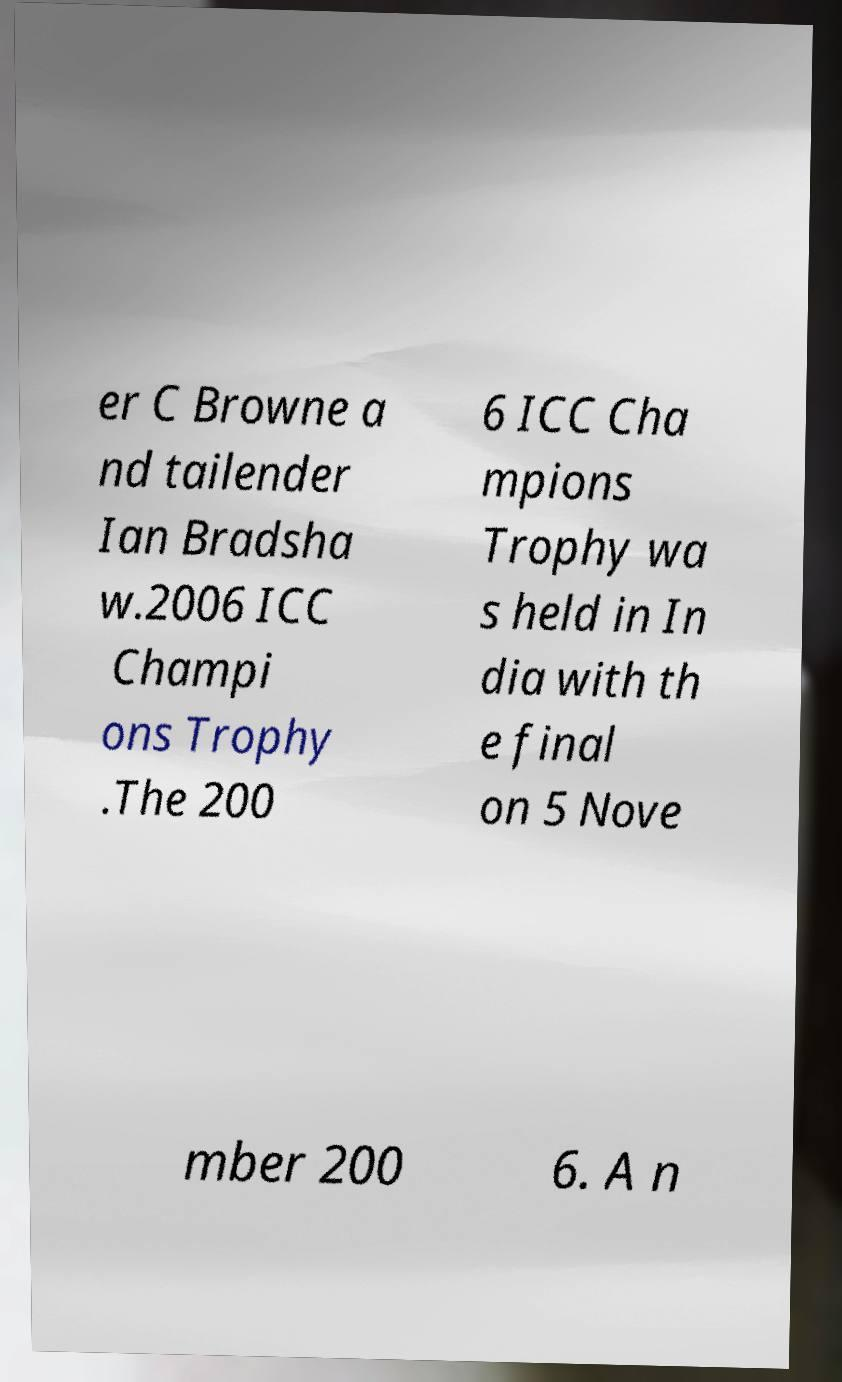Could you extract and type out the text from this image? er C Browne a nd tailender Ian Bradsha w.2006 ICC Champi ons Trophy .The 200 6 ICC Cha mpions Trophy wa s held in In dia with th e final on 5 Nove mber 200 6. A n 